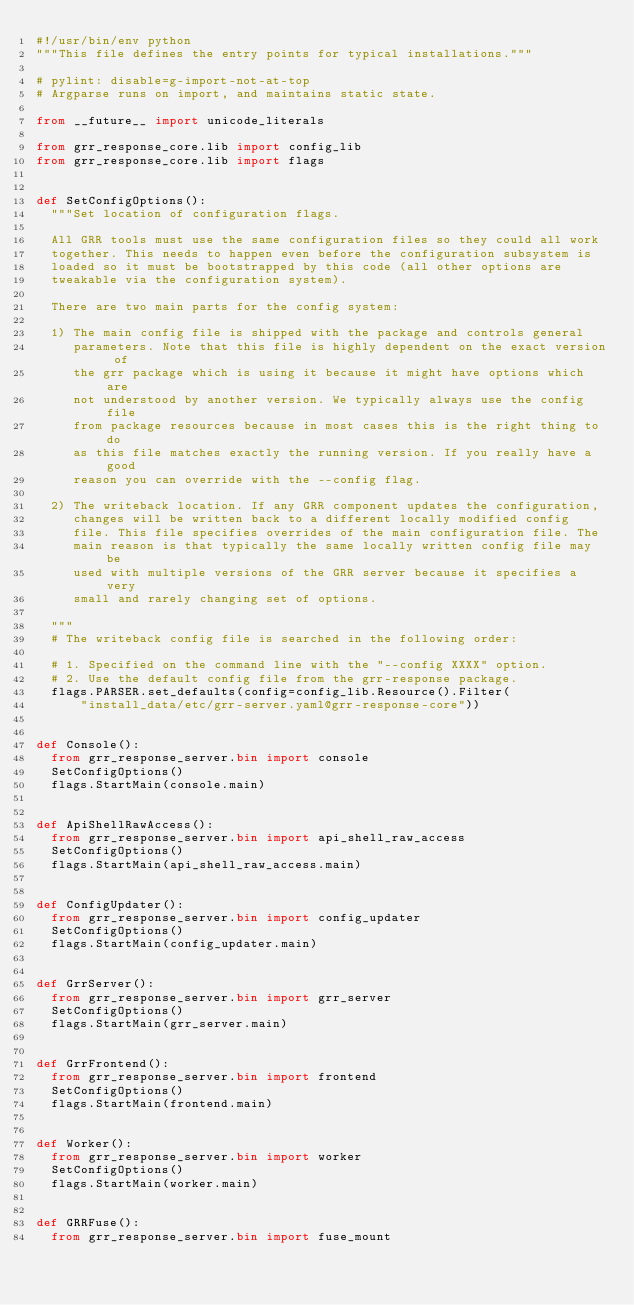<code> <loc_0><loc_0><loc_500><loc_500><_Python_>#!/usr/bin/env python
"""This file defines the entry points for typical installations."""

# pylint: disable=g-import-not-at-top
# Argparse runs on import, and maintains static state.

from __future__ import unicode_literals

from grr_response_core.lib import config_lib
from grr_response_core.lib import flags


def SetConfigOptions():
  """Set location of configuration flags.

  All GRR tools must use the same configuration files so they could all work
  together. This needs to happen even before the configuration subsystem is
  loaded so it must be bootstrapped by this code (all other options are
  tweakable via the configuration system).

  There are two main parts for the config system:

  1) The main config file is shipped with the package and controls general
     parameters. Note that this file is highly dependent on the exact version of
     the grr package which is using it because it might have options which are
     not understood by another version. We typically always use the config file
     from package resources because in most cases this is the right thing to do
     as this file matches exactly the running version. If you really have a good
     reason you can override with the --config flag.

  2) The writeback location. If any GRR component updates the configuration,
     changes will be written back to a different locally modified config
     file. This file specifies overrides of the main configuration file. The
     main reason is that typically the same locally written config file may be
     used with multiple versions of the GRR server because it specifies a very
     small and rarely changing set of options.

  """
  # The writeback config file is searched in the following order:

  # 1. Specified on the command line with the "--config XXXX" option.
  # 2. Use the default config file from the grr-response package.
  flags.PARSER.set_defaults(config=config_lib.Resource().Filter(
      "install_data/etc/grr-server.yaml@grr-response-core"))


def Console():
  from grr_response_server.bin import console
  SetConfigOptions()
  flags.StartMain(console.main)


def ApiShellRawAccess():
  from grr_response_server.bin import api_shell_raw_access
  SetConfigOptions()
  flags.StartMain(api_shell_raw_access.main)


def ConfigUpdater():
  from grr_response_server.bin import config_updater
  SetConfigOptions()
  flags.StartMain(config_updater.main)


def GrrServer():
  from grr_response_server.bin import grr_server
  SetConfigOptions()
  flags.StartMain(grr_server.main)


def GrrFrontend():
  from grr_response_server.bin import frontend
  SetConfigOptions()
  flags.StartMain(frontend.main)


def Worker():
  from grr_response_server.bin import worker
  SetConfigOptions()
  flags.StartMain(worker.main)


def GRRFuse():
  from grr_response_server.bin import fuse_mount</code> 